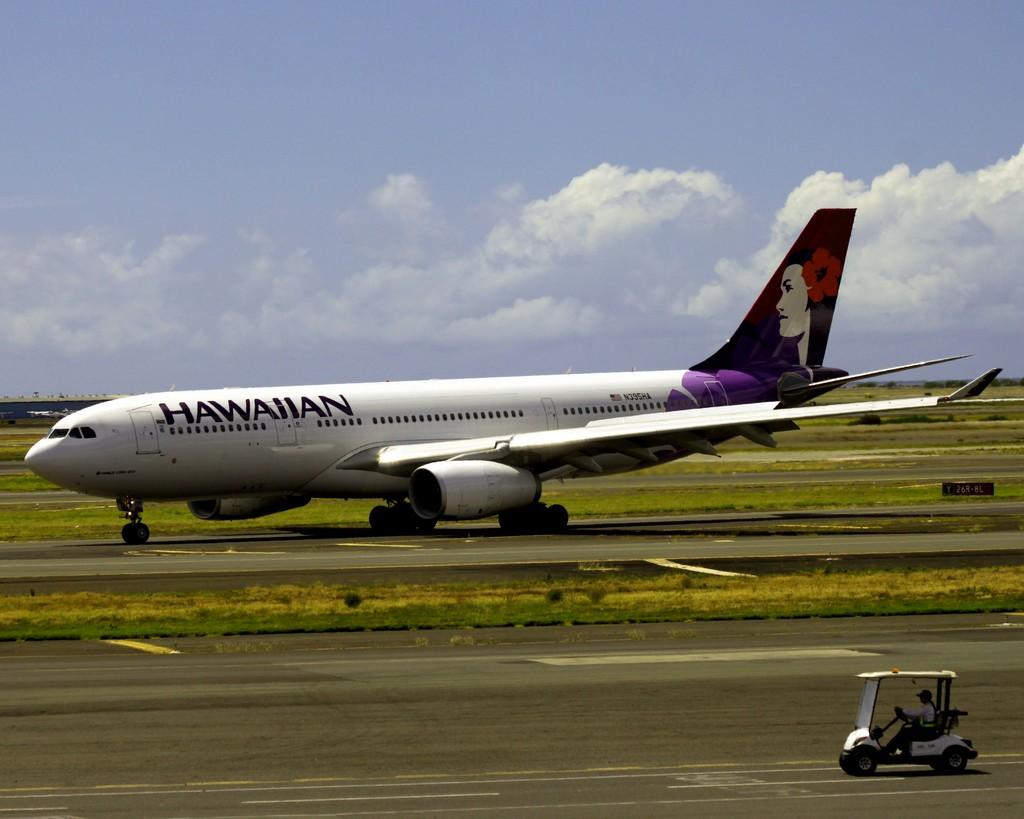What is the person in the image doing? There is a person riding a vehicle in the image. What other object can be seen in the image? There is an aircraft in the image. What colors are visible in the sky in the background? The sky in the background is blue and white. What type of body is being used to control the aircraft in the image? There is no body visible in the image, and the aircraft does not appear to be controlled by a person. Can you see any rifles in the image? There are no rifles present in the image. 